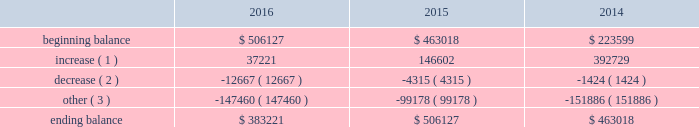The principal components of eog's rollforward of valuation allowances for deferred tax assets were as follows ( in thousands ) : .
( 1 ) increase in valuation allowance related to the generation of tax net operating losses and other deferred tax assets .
( 2 ) decrease in valuation allowance associated with adjustments to certain deferred tax assets and their related allowance .
( 3 ) represents dispositions/revisions/foreign exchange rate variances and the effect of statutory income tax rate changes .
The balance of unrecognized tax benefits at december 31 , 2016 , was $ 36 million , of which $ 2 million may potentially have an earnings impact .
Eog records interest and penalties related to unrecognized tax benefits to its income tax provision .
Currently , $ 2 million of interest has been recognized in the consolidated statements of income and comprehensive income .
Eog does not anticipate that the amount of the unrecognized tax benefits will significantly change during the next twelve months .
Eog and its subsidiaries file income tax returns and are subject to tax audits in the united states and various state , local and foreign jurisdictions .
Eog's earliest open tax years in its principal jurisdictions are as follows : united states federal ( 2011 ) , canada ( 2012 ) , united kingdom ( 2015 ) , trinidad ( 2010 ) and china ( 2008 ) .
Eog's foreign subsidiaries' undistributed earnings of approximately $ 2 billion at december 31 , 2016 , are no longer considered to be permanently reinvested outside the united states and , accordingly , eog has cumulatively recorded $ 280 million of united states federal , foreign and state deferred income taxes .
Eog changed its permanent reinvestment assertion in 2014 .
In 2016 , eog's alternative minimum tax ( amt ) credits were reduced by $ 21 million mostly as a result of carry-back claims and certain elections .
Remaining amt credits of $ 758 million , resulting from amt paid in prior years , will be carried forward indefinitely until they are used to offset regular income taxes in future periods .
The ability of eog to utilize these amt credit carryforwards to reduce federal income taxes may become subject to various limitations under the internal revenue code .
Such limitations may arise if certain ownership changes ( as defined for income tax purposes ) were to occur .
As of december 31 , 2016 , eog had state income tax net operating losses ( nols ) being carried forward of approximately $ 1.6 billion , which , if unused , expire between 2017 and 2035 .
During 2016 , eog's united kingdom subsidiary incurred a tax nol of approximately $ 38 million which , along with prior years' nols of $ 740 million , will be carried forward indefinitely .
As described above , these nols have been evaluated for the likelihood of future utilization , and valuation allowances have been established for the portion of these deferred tax assets that do not meet the "more likely than not" threshold .
Employee benefit plans stock-based compensation during 2016 , eog maintained various stock-based compensation plans as discussed below .
Eog recognizes compensation expense on grants of stock options , sars , restricted stock and restricted stock units , performance units and performance stock , and grants made under the eog resources , inc .
Employee stock purchase plan ( espp ) .
Stock-based compensation expense is calculated based upon the grant date estimated fair value of the awards , net of forfeitures , based upon eog's historical employee turnover rate .
Compensation expense is amortized over the shorter of the vesting period or the period from date of grant until the date the employee becomes eligible to retire without company approval. .
What is the lowest beginning balance observed during 2014-2016? 
Rationale: it is the minimum value observed in this period .
Computations: table_min(beginning balance, none)
Answer: 223599.0. 